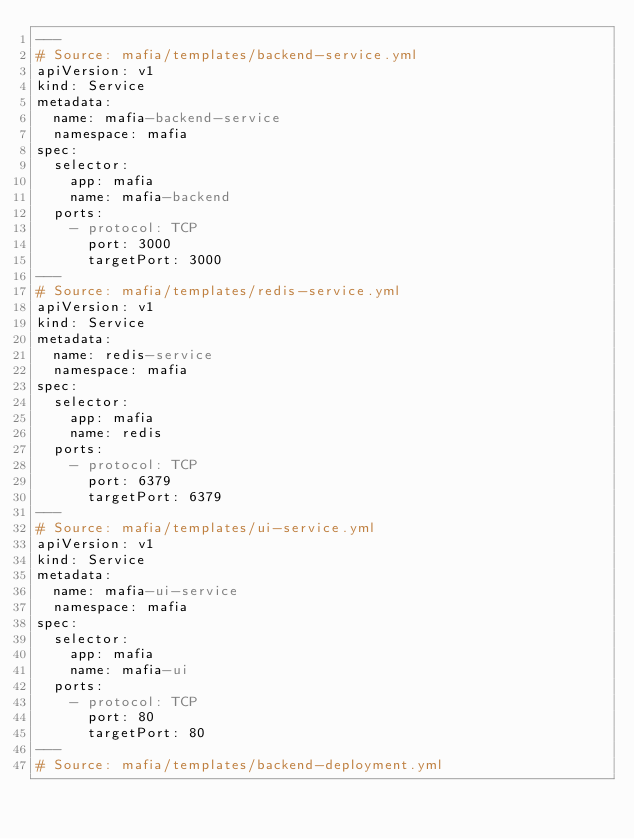Convert code to text. <code><loc_0><loc_0><loc_500><loc_500><_YAML_>---
# Source: mafia/templates/backend-service.yml
apiVersion: v1
kind: Service
metadata:
  name: mafia-backend-service
  namespace: mafia
spec:
  selector:
    app: mafia
    name: mafia-backend
  ports:
    - protocol: TCP
      port: 3000
      targetPort: 3000
---
# Source: mafia/templates/redis-service.yml
apiVersion: v1
kind: Service
metadata:
  name: redis-service
  namespace: mafia
spec:
  selector:
    app: mafia
    name: redis
  ports:
    - protocol: TCP
      port: 6379
      targetPort: 6379
---
# Source: mafia/templates/ui-service.yml
apiVersion: v1
kind: Service
metadata:
  name: mafia-ui-service
  namespace: mafia
spec:
  selector:
    app: mafia
    name: mafia-ui
  ports:
    - protocol: TCP
      port: 80
      targetPort: 80
---
# Source: mafia/templates/backend-deployment.yml</code> 